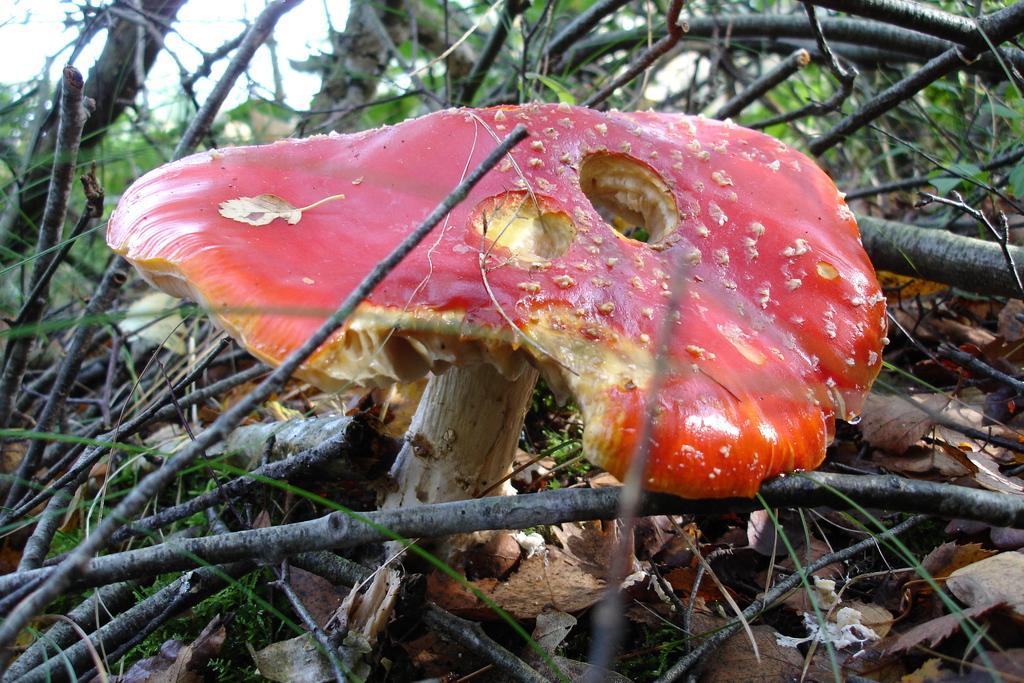In one or two sentences, can you explain what this image depicts? This image consists of a mushroom in red color. At the bottom, there are dried leaves and stems. In the background, we can see small plants. 